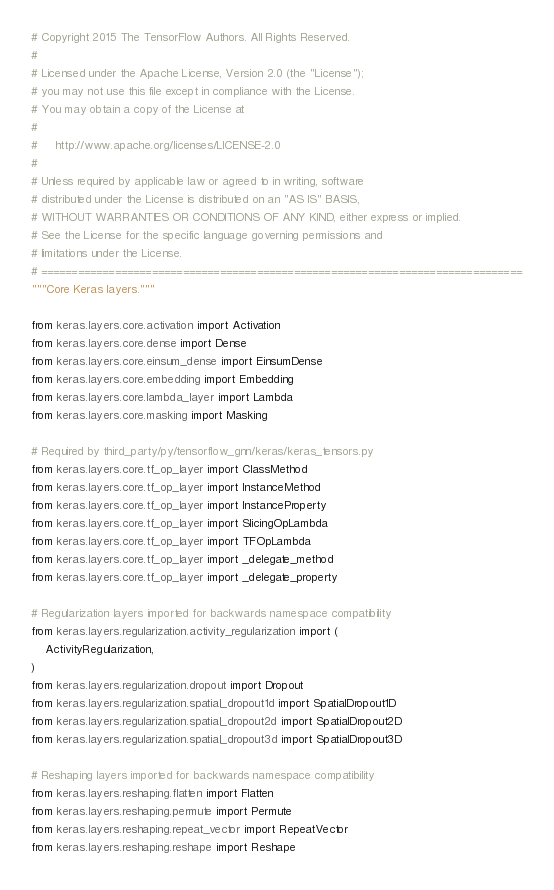<code> <loc_0><loc_0><loc_500><loc_500><_Python_># Copyright 2015 The TensorFlow Authors. All Rights Reserved.
#
# Licensed under the Apache License, Version 2.0 (the "License");
# you may not use this file except in compliance with the License.
# You may obtain a copy of the License at
#
#     http://www.apache.org/licenses/LICENSE-2.0
#
# Unless required by applicable law or agreed to in writing, software
# distributed under the License is distributed on an "AS IS" BASIS,
# WITHOUT WARRANTIES OR CONDITIONS OF ANY KIND, either express or implied.
# See the License for the specific language governing permissions and
# limitations under the License.
# ==============================================================================
"""Core Keras layers."""

from keras.layers.core.activation import Activation
from keras.layers.core.dense import Dense
from keras.layers.core.einsum_dense import EinsumDense
from keras.layers.core.embedding import Embedding
from keras.layers.core.lambda_layer import Lambda
from keras.layers.core.masking import Masking

# Required by third_party/py/tensorflow_gnn/keras/keras_tensors.py
from keras.layers.core.tf_op_layer import ClassMethod
from keras.layers.core.tf_op_layer import InstanceMethod
from keras.layers.core.tf_op_layer import InstanceProperty
from keras.layers.core.tf_op_layer import SlicingOpLambda
from keras.layers.core.tf_op_layer import TFOpLambda
from keras.layers.core.tf_op_layer import _delegate_method
from keras.layers.core.tf_op_layer import _delegate_property

# Regularization layers imported for backwards namespace compatibility
from keras.layers.regularization.activity_regularization import (
    ActivityRegularization,
)
from keras.layers.regularization.dropout import Dropout
from keras.layers.regularization.spatial_dropout1d import SpatialDropout1D
from keras.layers.regularization.spatial_dropout2d import SpatialDropout2D
from keras.layers.regularization.spatial_dropout3d import SpatialDropout3D

# Reshaping layers imported for backwards namespace compatibility
from keras.layers.reshaping.flatten import Flatten
from keras.layers.reshaping.permute import Permute
from keras.layers.reshaping.repeat_vector import RepeatVector
from keras.layers.reshaping.reshape import Reshape
</code> 